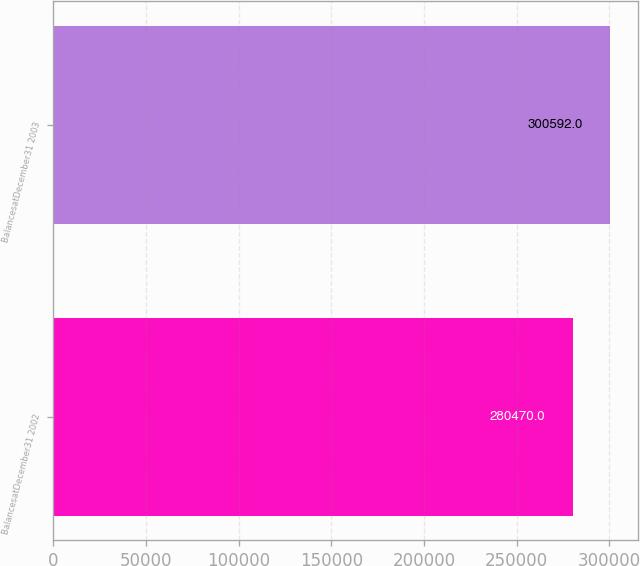Convert chart. <chart><loc_0><loc_0><loc_500><loc_500><bar_chart><fcel>BalancesatDecember31 2002<fcel>BalancesatDecember31 2003<nl><fcel>280470<fcel>300592<nl></chart> 